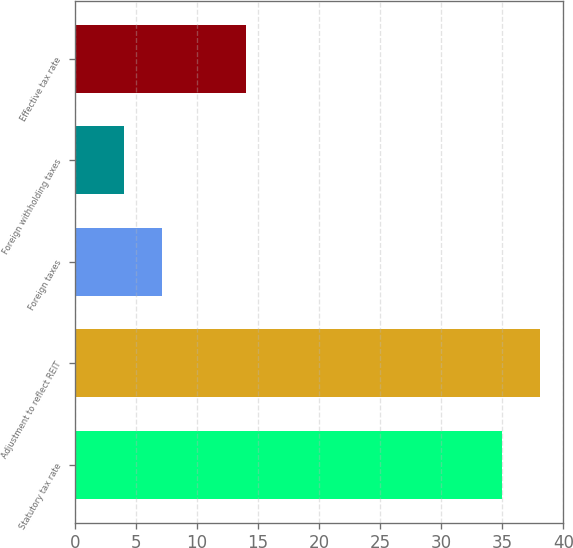<chart> <loc_0><loc_0><loc_500><loc_500><bar_chart><fcel>Statutory tax rate<fcel>Adjustment to reflect REIT<fcel>Foreign taxes<fcel>Foreign withholding taxes<fcel>Effective tax rate<nl><fcel>35<fcel>38.1<fcel>7.1<fcel>4<fcel>14<nl></chart> 